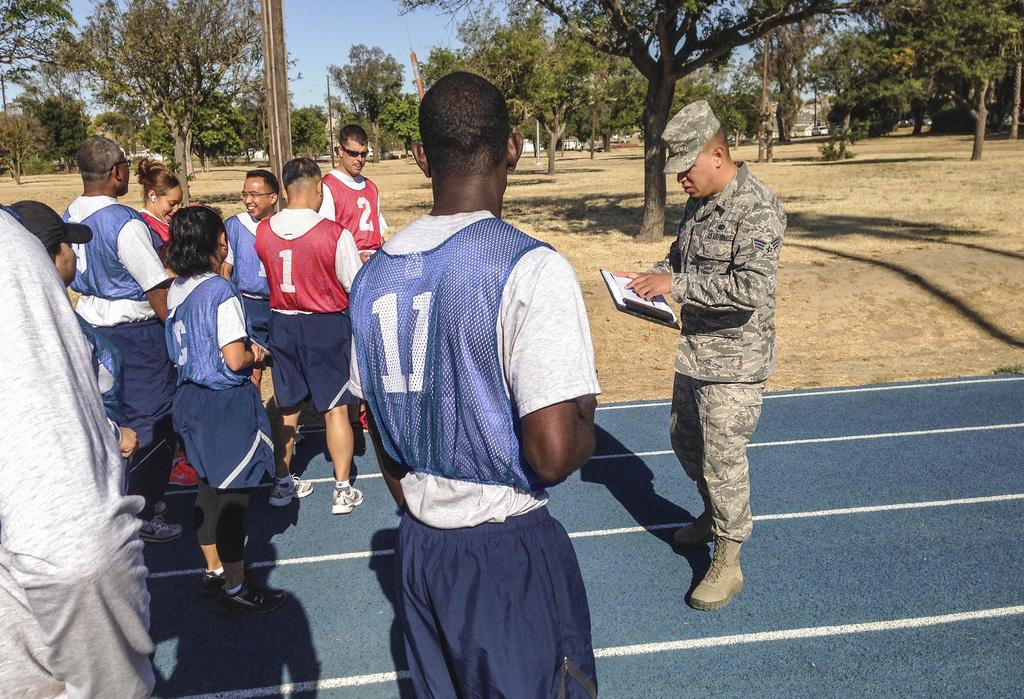How many people are in the image? There is a group of people in the image, but the exact number cannot be determined from the provided facts. What is the ground like in the image? The ground is visible in the image, but its specific characteristics are not mentioned. What type of vegetation is present in the image? There are trees in the image. What else can be seen in the image besides the people and trees? There are vehicles in the image. What is visible in the background of the image? The sky is visible in the background of the image. What type of bottle is being used to serve eggnog in the image? There is no bottle or eggnog present in the image. 